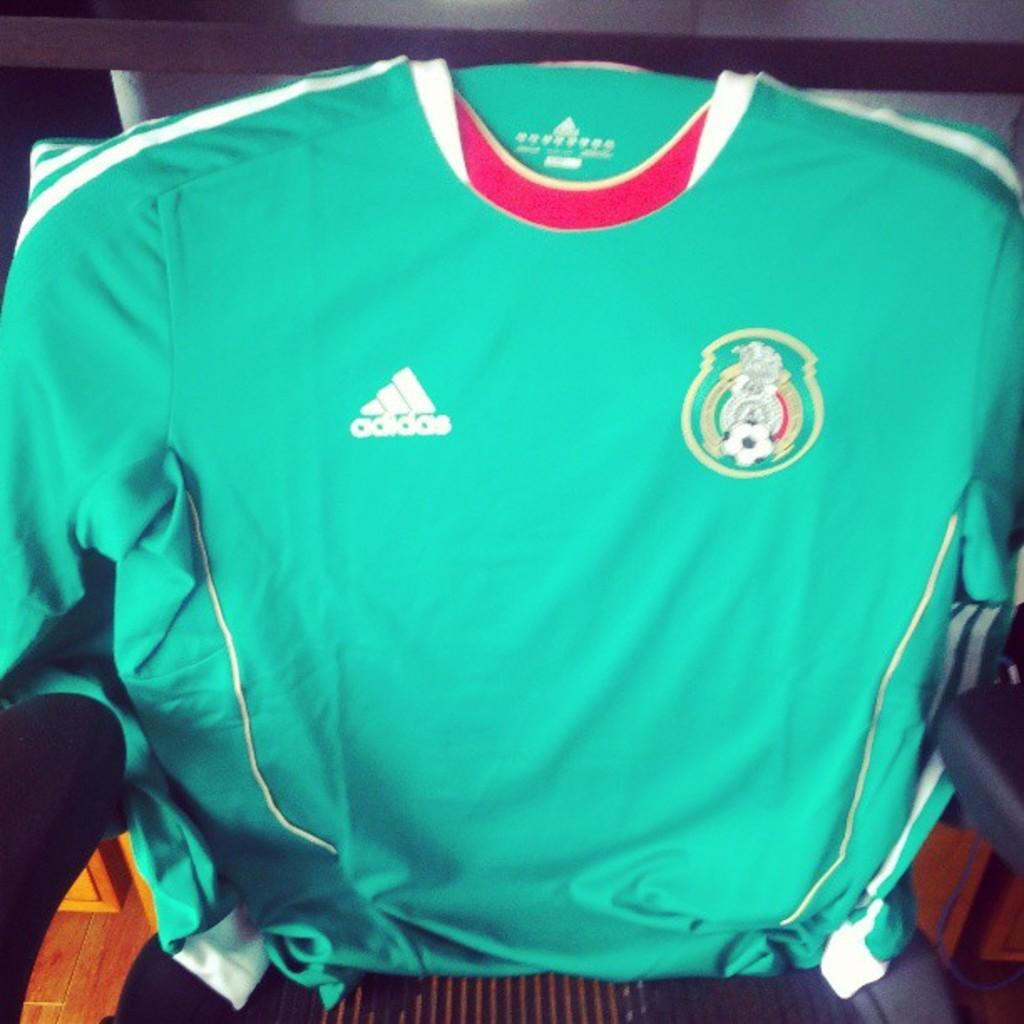<image>
Offer a succinct explanation of the picture presented. a shirt that has the word adidas on it 